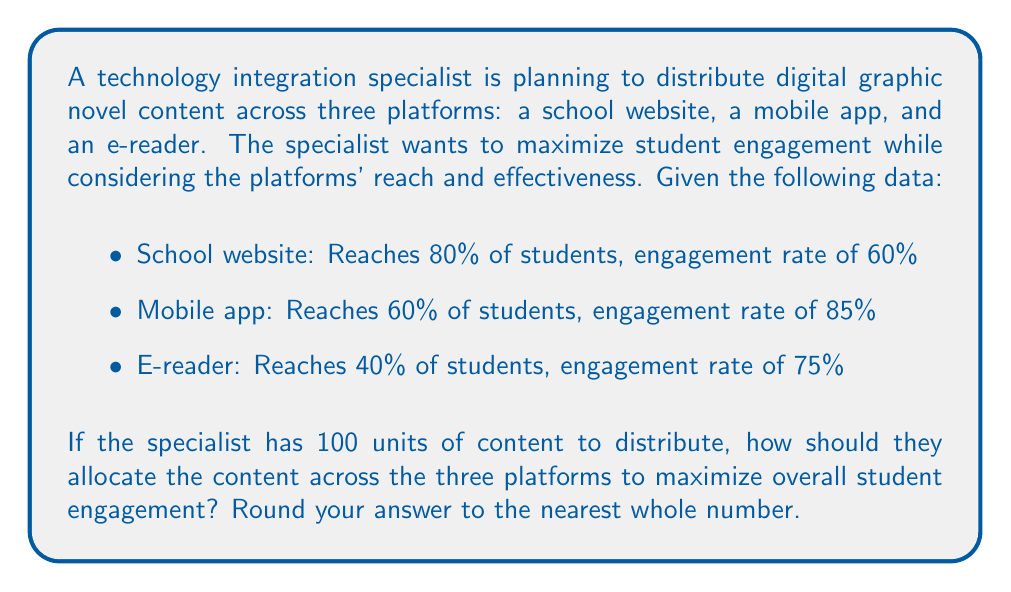Can you solve this math problem? To solve this problem, we'll use game theory concepts to maximize the overall engagement. Let's approach this step-by-step:

1) First, let's define variables:
   $x$ = units allocated to school website
   $y$ = units allocated to mobile app
   $z$ = units allocated to e-reader

2) We know that the total content is 100 units:
   $x + y + z = 100$

3) Now, let's calculate the engagement for each platform:
   School website: $0.80 \times 0.60 \times x = 0.48x$
   Mobile app: $0.60 \times 0.85 \times y = 0.51y$
   E-reader: $0.40 \times 0.75 \times z = 0.30z$

4) Our objective is to maximize total engagement:
   $E = 0.48x + 0.51y + 0.30z$

5) This is a linear optimization problem. In such cases, the optimal solution often lies at the extremes. The platform with the highest engagement coefficient should be prioritized.

6) The engagement coefficients are:
   School website: 0.48
   Mobile app: 0.51
   E-reader: 0.30

7) The mobile app has the highest coefficient, so we should allocate as much content as possible to it, followed by the school website, and then the e-reader.

8) Optimal allocation:
   Mobile app: $y = 60$ (maximum reach)
   School website: $x = 40$ (remaining content)
   E-reader: $z = 0$

9) Let's verify:
   $60 + 40 + 0 = 100$ (total content constraint satisfied)

10) Total engagement:
    $E = 0.48(40) + 0.51(60) + 0.30(0) = 19.2 + 30.6 = 49.8$

This allocation maximizes the overall student engagement given the constraints.
Answer: The optimal distribution is 60 units to the mobile app and 40 units to the school website, with 0 units to the e-reader. 